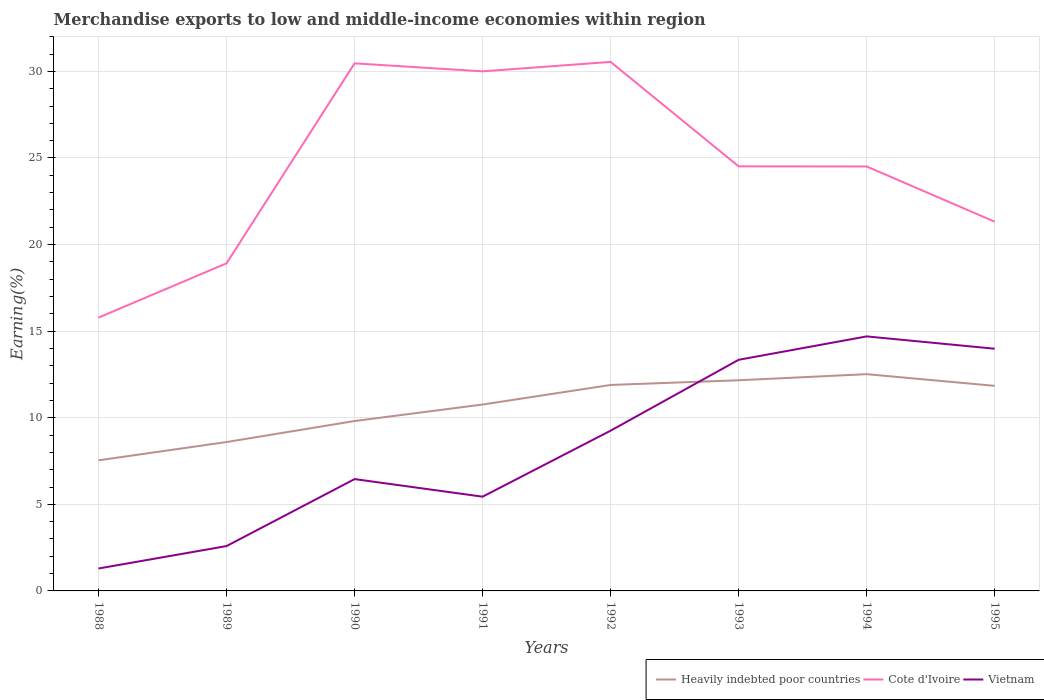How many different coloured lines are there?
Keep it short and to the point. 3. Across all years, what is the maximum percentage of amount earned from merchandise exports in Cote d'Ivoire?
Provide a short and direct response. 15.78. What is the total percentage of amount earned from merchandise exports in Vietnam in the graph?
Keep it short and to the point. -7.9. What is the difference between the highest and the second highest percentage of amount earned from merchandise exports in Heavily indebted poor countries?
Provide a succinct answer. 4.97. What is the difference between the highest and the lowest percentage of amount earned from merchandise exports in Vietnam?
Your response must be concise. 4. Is the percentage of amount earned from merchandise exports in Cote d'Ivoire strictly greater than the percentage of amount earned from merchandise exports in Heavily indebted poor countries over the years?
Your answer should be compact. No. What is the difference between two consecutive major ticks on the Y-axis?
Give a very brief answer. 5. Are the values on the major ticks of Y-axis written in scientific E-notation?
Offer a terse response. No. How are the legend labels stacked?
Give a very brief answer. Horizontal. What is the title of the graph?
Your answer should be compact. Merchandise exports to low and middle-income economies within region. Does "Lesotho" appear as one of the legend labels in the graph?
Make the answer very short. No. What is the label or title of the X-axis?
Ensure brevity in your answer.  Years. What is the label or title of the Y-axis?
Your response must be concise. Earning(%). What is the Earning(%) in Heavily indebted poor countries in 1988?
Keep it short and to the point. 7.54. What is the Earning(%) in Cote d'Ivoire in 1988?
Ensure brevity in your answer.  15.78. What is the Earning(%) in Vietnam in 1988?
Keep it short and to the point. 1.29. What is the Earning(%) of Heavily indebted poor countries in 1989?
Your answer should be very brief. 8.6. What is the Earning(%) in Cote d'Ivoire in 1989?
Offer a very short reply. 18.92. What is the Earning(%) in Vietnam in 1989?
Your answer should be compact. 2.59. What is the Earning(%) of Heavily indebted poor countries in 1990?
Offer a very short reply. 9.81. What is the Earning(%) in Cote d'Ivoire in 1990?
Offer a terse response. 30.46. What is the Earning(%) of Vietnam in 1990?
Your response must be concise. 6.46. What is the Earning(%) in Heavily indebted poor countries in 1991?
Offer a terse response. 10.76. What is the Earning(%) in Cote d'Ivoire in 1991?
Your answer should be very brief. 30. What is the Earning(%) of Vietnam in 1991?
Give a very brief answer. 5.44. What is the Earning(%) of Heavily indebted poor countries in 1992?
Your response must be concise. 11.89. What is the Earning(%) of Cote d'Ivoire in 1992?
Your response must be concise. 30.55. What is the Earning(%) of Vietnam in 1992?
Your response must be concise. 9.25. What is the Earning(%) of Heavily indebted poor countries in 1993?
Make the answer very short. 12.16. What is the Earning(%) in Cote d'Ivoire in 1993?
Ensure brevity in your answer.  24.51. What is the Earning(%) in Vietnam in 1993?
Keep it short and to the point. 13.35. What is the Earning(%) of Heavily indebted poor countries in 1994?
Ensure brevity in your answer.  12.52. What is the Earning(%) in Cote d'Ivoire in 1994?
Give a very brief answer. 24.51. What is the Earning(%) in Vietnam in 1994?
Provide a succinct answer. 14.7. What is the Earning(%) of Heavily indebted poor countries in 1995?
Offer a terse response. 11.84. What is the Earning(%) of Cote d'Ivoire in 1995?
Your response must be concise. 21.32. What is the Earning(%) of Vietnam in 1995?
Ensure brevity in your answer.  13.98. Across all years, what is the maximum Earning(%) in Heavily indebted poor countries?
Give a very brief answer. 12.52. Across all years, what is the maximum Earning(%) of Cote d'Ivoire?
Make the answer very short. 30.55. Across all years, what is the maximum Earning(%) of Vietnam?
Your answer should be very brief. 14.7. Across all years, what is the minimum Earning(%) of Heavily indebted poor countries?
Your answer should be compact. 7.54. Across all years, what is the minimum Earning(%) in Cote d'Ivoire?
Your answer should be very brief. 15.78. Across all years, what is the minimum Earning(%) in Vietnam?
Your answer should be very brief. 1.29. What is the total Earning(%) in Heavily indebted poor countries in the graph?
Ensure brevity in your answer.  85.12. What is the total Earning(%) in Cote d'Ivoire in the graph?
Ensure brevity in your answer.  196.05. What is the total Earning(%) in Vietnam in the graph?
Your answer should be very brief. 67.06. What is the difference between the Earning(%) in Heavily indebted poor countries in 1988 and that in 1989?
Offer a very short reply. -1.06. What is the difference between the Earning(%) of Cote d'Ivoire in 1988 and that in 1989?
Provide a short and direct response. -3.14. What is the difference between the Earning(%) of Vietnam in 1988 and that in 1989?
Ensure brevity in your answer.  -1.3. What is the difference between the Earning(%) of Heavily indebted poor countries in 1988 and that in 1990?
Keep it short and to the point. -2.27. What is the difference between the Earning(%) of Cote d'Ivoire in 1988 and that in 1990?
Keep it short and to the point. -14.68. What is the difference between the Earning(%) in Vietnam in 1988 and that in 1990?
Offer a terse response. -5.16. What is the difference between the Earning(%) of Heavily indebted poor countries in 1988 and that in 1991?
Give a very brief answer. -3.22. What is the difference between the Earning(%) in Cote d'Ivoire in 1988 and that in 1991?
Offer a very short reply. -14.22. What is the difference between the Earning(%) of Vietnam in 1988 and that in 1991?
Offer a terse response. -4.15. What is the difference between the Earning(%) in Heavily indebted poor countries in 1988 and that in 1992?
Offer a terse response. -4.35. What is the difference between the Earning(%) in Cote d'Ivoire in 1988 and that in 1992?
Provide a short and direct response. -14.76. What is the difference between the Earning(%) in Vietnam in 1988 and that in 1992?
Your response must be concise. -7.96. What is the difference between the Earning(%) of Heavily indebted poor countries in 1988 and that in 1993?
Make the answer very short. -4.62. What is the difference between the Earning(%) of Cote d'Ivoire in 1988 and that in 1993?
Make the answer very short. -8.73. What is the difference between the Earning(%) of Vietnam in 1988 and that in 1993?
Give a very brief answer. -12.05. What is the difference between the Earning(%) in Heavily indebted poor countries in 1988 and that in 1994?
Offer a terse response. -4.97. What is the difference between the Earning(%) in Cote d'Ivoire in 1988 and that in 1994?
Provide a succinct answer. -8.73. What is the difference between the Earning(%) of Vietnam in 1988 and that in 1994?
Your answer should be very brief. -13.4. What is the difference between the Earning(%) in Heavily indebted poor countries in 1988 and that in 1995?
Give a very brief answer. -4.3. What is the difference between the Earning(%) in Cote d'Ivoire in 1988 and that in 1995?
Offer a very short reply. -5.54. What is the difference between the Earning(%) in Vietnam in 1988 and that in 1995?
Make the answer very short. -12.69. What is the difference between the Earning(%) in Heavily indebted poor countries in 1989 and that in 1990?
Offer a terse response. -1.21. What is the difference between the Earning(%) of Cote d'Ivoire in 1989 and that in 1990?
Provide a short and direct response. -11.55. What is the difference between the Earning(%) of Vietnam in 1989 and that in 1990?
Provide a short and direct response. -3.87. What is the difference between the Earning(%) of Heavily indebted poor countries in 1989 and that in 1991?
Make the answer very short. -2.17. What is the difference between the Earning(%) of Cote d'Ivoire in 1989 and that in 1991?
Make the answer very short. -11.08. What is the difference between the Earning(%) of Vietnam in 1989 and that in 1991?
Offer a terse response. -2.85. What is the difference between the Earning(%) in Heavily indebted poor countries in 1989 and that in 1992?
Ensure brevity in your answer.  -3.3. What is the difference between the Earning(%) in Cote d'Ivoire in 1989 and that in 1992?
Keep it short and to the point. -11.63. What is the difference between the Earning(%) in Vietnam in 1989 and that in 1992?
Provide a succinct answer. -6.66. What is the difference between the Earning(%) in Heavily indebted poor countries in 1989 and that in 1993?
Provide a short and direct response. -3.57. What is the difference between the Earning(%) of Cote d'Ivoire in 1989 and that in 1993?
Offer a terse response. -5.6. What is the difference between the Earning(%) in Vietnam in 1989 and that in 1993?
Your answer should be compact. -10.76. What is the difference between the Earning(%) of Heavily indebted poor countries in 1989 and that in 1994?
Your answer should be very brief. -3.92. What is the difference between the Earning(%) of Cote d'Ivoire in 1989 and that in 1994?
Ensure brevity in your answer.  -5.59. What is the difference between the Earning(%) of Vietnam in 1989 and that in 1994?
Your response must be concise. -12.11. What is the difference between the Earning(%) in Heavily indebted poor countries in 1989 and that in 1995?
Offer a terse response. -3.24. What is the difference between the Earning(%) of Cote d'Ivoire in 1989 and that in 1995?
Give a very brief answer. -2.4. What is the difference between the Earning(%) of Vietnam in 1989 and that in 1995?
Offer a very short reply. -11.4. What is the difference between the Earning(%) in Heavily indebted poor countries in 1990 and that in 1991?
Your response must be concise. -0.95. What is the difference between the Earning(%) in Cote d'Ivoire in 1990 and that in 1991?
Provide a succinct answer. 0.46. What is the difference between the Earning(%) of Vietnam in 1990 and that in 1991?
Your response must be concise. 1.02. What is the difference between the Earning(%) of Heavily indebted poor countries in 1990 and that in 1992?
Offer a terse response. -2.08. What is the difference between the Earning(%) in Cote d'Ivoire in 1990 and that in 1992?
Keep it short and to the point. -0.08. What is the difference between the Earning(%) in Vietnam in 1990 and that in 1992?
Keep it short and to the point. -2.8. What is the difference between the Earning(%) in Heavily indebted poor countries in 1990 and that in 1993?
Make the answer very short. -2.35. What is the difference between the Earning(%) of Cote d'Ivoire in 1990 and that in 1993?
Make the answer very short. 5.95. What is the difference between the Earning(%) in Vietnam in 1990 and that in 1993?
Provide a short and direct response. -6.89. What is the difference between the Earning(%) of Heavily indebted poor countries in 1990 and that in 1994?
Give a very brief answer. -2.71. What is the difference between the Earning(%) in Cote d'Ivoire in 1990 and that in 1994?
Offer a very short reply. 5.95. What is the difference between the Earning(%) of Vietnam in 1990 and that in 1994?
Offer a very short reply. -8.24. What is the difference between the Earning(%) of Heavily indebted poor countries in 1990 and that in 1995?
Your answer should be very brief. -2.03. What is the difference between the Earning(%) in Cote d'Ivoire in 1990 and that in 1995?
Give a very brief answer. 9.14. What is the difference between the Earning(%) in Vietnam in 1990 and that in 1995?
Your answer should be very brief. -7.53. What is the difference between the Earning(%) in Heavily indebted poor countries in 1991 and that in 1992?
Keep it short and to the point. -1.13. What is the difference between the Earning(%) in Cote d'Ivoire in 1991 and that in 1992?
Provide a succinct answer. -0.55. What is the difference between the Earning(%) in Vietnam in 1991 and that in 1992?
Offer a terse response. -3.81. What is the difference between the Earning(%) of Heavily indebted poor countries in 1991 and that in 1993?
Your response must be concise. -1.4. What is the difference between the Earning(%) of Cote d'Ivoire in 1991 and that in 1993?
Ensure brevity in your answer.  5.49. What is the difference between the Earning(%) in Vietnam in 1991 and that in 1993?
Your answer should be very brief. -7.9. What is the difference between the Earning(%) of Heavily indebted poor countries in 1991 and that in 1994?
Make the answer very short. -1.75. What is the difference between the Earning(%) in Cote d'Ivoire in 1991 and that in 1994?
Provide a succinct answer. 5.49. What is the difference between the Earning(%) in Vietnam in 1991 and that in 1994?
Your response must be concise. -9.25. What is the difference between the Earning(%) in Heavily indebted poor countries in 1991 and that in 1995?
Offer a terse response. -1.08. What is the difference between the Earning(%) in Cote d'Ivoire in 1991 and that in 1995?
Give a very brief answer. 8.68. What is the difference between the Earning(%) of Vietnam in 1991 and that in 1995?
Offer a very short reply. -8.54. What is the difference between the Earning(%) in Heavily indebted poor countries in 1992 and that in 1993?
Provide a short and direct response. -0.27. What is the difference between the Earning(%) of Cote d'Ivoire in 1992 and that in 1993?
Make the answer very short. 6.03. What is the difference between the Earning(%) of Vietnam in 1992 and that in 1993?
Offer a terse response. -4.09. What is the difference between the Earning(%) of Heavily indebted poor countries in 1992 and that in 1994?
Your response must be concise. -0.62. What is the difference between the Earning(%) of Cote d'Ivoire in 1992 and that in 1994?
Your answer should be very brief. 6.04. What is the difference between the Earning(%) in Vietnam in 1992 and that in 1994?
Give a very brief answer. -5.44. What is the difference between the Earning(%) of Heavily indebted poor countries in 1992 and that in 1995?
Offer a very short reply. 0.05. What is the difference between the Earning(%) of Cote d'Ivoire in 1992 and that in 1995?
Your answer should be compact. 9.23. What is the difference between the Earning(%) in Vietnam in 1992 and that in 1995?
Ensure brevity in your answer.  -4.73. What is the difference between the Earning(%) in Heavily indebted poor countries in 1993 and that in 1994?
Give a very brief answer. -0.35. What is the difference between the Earning(%) of Cote d'Ivoire in 1993 and that in 1994?
Ensure brevity in your answer.  0.01. What is the difference between the Earning(%) of Vietnam in 1993 and that in 1994?
Your answer should be compact. -1.35. What is the difference between the Earning(%) in Heavily indebted poor countries in 1993 and that in 1995?
Offer a very short reply. 0.32. What is the difference between the Earning(%) of Cote d'Ivoire in 1993 and that in 1995?
Provide a succinct answer. 3.19. What is the difference between the Earning(%) in Vietnam in 1993 and that in 1995?
Ensure brevity in your answer.  -0.64. What is the difference between the Earning(%) in Heavily indebted poor countries in 1994 and that in 1995?
Ensure brevity in your answer.  0.67. What is the difference between the Earning(%) of Cote d'Ivoire in 1994 and that in 1995?
Ensure brevity in your answer.  3.19. What is the difference between the Earning(%) in Vietnam in 1994 and that in 1995?
Your answer should be very brief. 0.71. What is the difference between the Earning(%) of Heavily indebted poor countries in 1988 and the Earning(%) of Cote d'Ivoire in 1989?
Ensure brevity in your answer.  -11.38. What is the difference between the Earning(%) in Heavily indebted poor countries in 1988 and the Earning(%) in Vietnam in 1989?
Offer a very short reply. 4.95. What is the difference between the Earning(%) of Cote d'Ivoire in 1988 and the Earning(%) of Vietnam in 1989?
Offer a terse response. 13.19. What is the difference between the Earning(%) in Heavily indebted poor countries in 1988 and the Earning(%) in Cote d'Ivoire in 1990?
Provide a short and direct response. -22.92. What is the difference between the Earning(%) in Heavily indebted poor countries in 1988 and the Earning(%) in Vietnam in 1990?
Ensure brevity in your answer.  1.08. What is the difference between the Earning(%) of Cote d'Ivoire in 1988 and the Earning(%) of Vietnam in 1990?
Your answer should be compact. 9.32. What is the difference between the Earning(%) in Heavily indebted poor countries in 1988 and the Earning(%) in Cote d'Ivoire in 1991?
Offer a terse response. -22.46. What is the difference between the Earning(%) in Heavily indebted poor countries in 1988 and the Earning(%) in Vietnam in 1991?
Make the answer very short. 2.1. What is the difference between the Earning(%) of Cote d'Ivoire in 1988 and the Earning(%) of Vietnam in 1991?
Provide a short and direct response. 10.34. What is the difference between the Earning(%) of Heavily indebted poor countries in 1988 and the Earning(%) of Cote d'Ivoire in 1992?
Provide a succinct answer. -23.01. What is the difference between the Earning(%) of Heavily indebted poor countries in 1988 and the Earning(%) of Vietnam in 1992?
Your response must be concise. -1.71. What is the difference between the Earning(%) of Cote d'Ivoire in 1988 and the Earning(%) of Vietnam in 1992?
Ensure brevity in your answer.  6.53. What is the difference between the Earning(%) of Heavily indebted poor countries in 1988 and the Earning(%) of Cote d'Ivoire in 1993?
Your answer should be compact. -16.97. What is the difference between the Earning(%) in Heavily indebted poor countries in 1988 and the Earning(%) in Vietnam in 1993?
Your answer should be very brief. -5.8. What is the difference between the Earning(%) in Cote d'Ivoire in 1988 and the Earning(%) in Vietnam in 1993?
Provide a succinct answer. 2.44. What is the difference between the Earning(%) in Heavily indebted poor countries in 1988 and the Earning(%) in Cote d'Ivoire in 1994?
Provide a succinct answer. -16.97. What is the difference between the Earning(%) of Heavily indebted poor countries in 1988 and the Earning(%) of Vietnam in 1994?
Offer a very short reply. -7.16. What is the difference between the Earning(%) in Cote d'Ivoire in 1988 and the Earning(%) in Vietnam in 1994?
Provide a succinct answer. 1.09. What is the difference between the Earning(%) in Heavily indebted poor countries in 1988 and the Earning(%) in Cote d'Ivoire in 1995?
Keep it short and to the point. -13.78. What is the difference between the Earning(%) of Heavily indebted poor countries in 1988 and the Earning(%) of Vietnam in 1995?
Provide a succinct answer. -6.44. What is the difference between the Earning(%) in Cote d'Ivoire in 1988 and the Earning(%) in Vietnam in 1995?
Keep it short and to the point. 1.8. What is the difference between the Earning(%) in Heavily indebted poor countries in 1989 and the Earning(%) in Cote d'Ivoire in 1990?
Give a very brief answer. -21.87. What is the difference between the Earning(%) of Heavily indebted poor countries in 1989 and the Earning(%) of Vietnam in 1990?
Keep it short and to the point. 2.14. What is the difference between the Earning(%) in Cote d'Ivoire in 1989 and the Earning(%) in Vietnam in 1990?
Offer a terse response. 12.46. What is the difference between the Earning(%) of Heavily indebted poor countries in 1989 and the Earning(%) of Cote d'Ivoire in 1991?
Provide a short and direct response. -21.4. What is the difference between the Earning(%) in Heavily indebted poor countries in 1989 and the Earning(%) in Vietnam in 1991?
Keep it short and to the point. 3.15. What is the difference between the Earning(%) in Cote d'Ivoire in 1989 and the Earning(%) in Vietnam in 1991?
Offer a very short reply. 13.48. What is the difference between the Earning(%) in Heavily indebted poor countries in 1989 and the Earning(%) in Cote d'Ivoire in 1992?
Ensure brevity in your answer.  -21.95. What is the difference between the Earning(%) of Heavily indebted poor countries in 1989 and the Earning(%) of Vietnam in 1992?
Offer a very short reply. -0.66. What is the difference between the Earning(%) of Cote d'Ivoire in 1989 and the Earning(%) of Vietnam in 1992?
Offer a very short reply. 9.66. What is the difference between the Earning(%) of Heavily indebted poor countries in 1989 and the Earning(%) of Cote d'Ivoire in 1993?
Provide a short and direct response. -15.92. What is the difference between the Earning(%) of Heavily indebted poor countries in 1989 and the Earning(%) of Vietnam in 1993?
Ensure brevity in your answer.  -4.75. What is the difference between the Earning(%) in Cote d'Ivoire in 1989 and the Earning(%) in Vietnam in 1993?
Keep it short and to the point. 5.57. What is the difference between the Earning(%) of Heavily indebted poor countries in 1989 and the Earning(%) of Cote d'Ivoire in 1994?
Provide a succinct answer. -15.91. What is the difference between the Earning(%) in Heavily indebted poor countries in 1989 and the Earning(%) in Vietnam in 1994?
Your response must be concise. -6.1. What is the difference between the Earning(%) of Cote d'Ivoire in 1989 and the Earning(%) of Vietnam in 1994?
Your response must be concise. 4.22. What is the difference between the Earning(%) in Heavily indebted poor countries in 1989 and the Earning(%) in Cote d'Ivoire in 1995?
Your answer should be very brief. -12.72. What is the difference between the Earning(%) in Heavily indebted poor countries in 1989 and the Earning(%) in Vietnam in 1995?
Ensure brevity in your answer.  -5.39. What is the difference between the Earning(%) of Cote d'Ivoire in 1989 and the Earning(%) of Vietnam in 1995?
Keep it short and to the point. 4.93. What is the difference between the Earning(%) in Heavily indebted poor countries in 1990 and the Earning(%) in Cote d'Ivoire in 1991?
Make the answer very short. -20.19. What is the difference between the Earning(%) of Heavily indebted poor countries in 1990 and the Earning(%) of Vietnam in 1991?
Your response must be concise. 4.37. What is the difference between the Earning(%) of Cote d'Ivoire in 1990 and the Earning(%) of Vietnam in 1991?
Your answer should be compact. 25.02. What is the difference between the Earning(%) of Heavily indebted poor countries in 1990 and the Earning(%) of Cote d'Ivoire in 1992?
Offer a terse response. -20.74. What is the difference between the Earning(%) of Heavily indebted poor countries in 1990 and the Earning(%) of Vietnam in 1992?
Keep it short and to the point. 0.56. What is the difference between the Earning(%) of Cote d'Ivoire in 1990 and the Earning(%) of Vietnam in 1992?
Ensure brevity in your answer.  21.21. What is the difference between the Earning(%) in Heavily indebted poor countries in 1990 and the Earning(%) in Cote d'Ivoire in 1993?
Ensure brevity in your answer.  -14.7. What is the difference between the Earning(%) of Heavily indebted poor countries in 1990 and the Earning(%) of Vietnam in 1993?
Your answer should be very brief. -3.53. What is the difference between the Earning(%) in Cote d'Ivoire in 1990 and the Earning(%) in Vietnam in 1993?
Your response must be concise. 17.12. What is the difference between the Earning(%) of Heavily indebted poor countries in 1990 and the Earning(%) of Cote d'Ivoire in 1994?
Ensure brevity in your answer.  -14.7. What is the difference between the Earning(%) in Heavily indebted poor countries in 1990 and the Earning(%) in Vietnam in 1994?
Make the answer very short. -4.89. What is the difference between the Earning(%) in Cote d'Ivoire in 1990 and the Earning(%) in Vietnam in 1994?
Provide a short and direct response. 15.77. What is the difference between the Earning(%) in Heavily indebted poor countries in 1990 and the Earning(%) in Cote d'Ivoire in 1995?
Provide a short and direct response. -11.51. What is the difference between the Earning(%) in Heavily indebted poor countries in 1990 and the Earning(%) in Vietnam in 1995?
Your answer should be very brief. -4.17. What is the difference between the Earning(%) of Cote d'Ivoire in 1990 and the Earning(%) of Vietnam in 1995?
Ensure brevity in your answer.  16.48. What is the difference between the Earning(%) in Heavily indebted poor countries in 1991 and the Earning(%) in Cote d'Ivoire in 1992?
Your response must be concise. -19.78. What is the difference between the Earning(%) of Heavily indebted poor countries in 1991 and the Earning(%) of Vietnam in 1992?
Make the answer very short. 1.51. What is the difference between the Earning(%) in Cote d'Ivoire in 1991 and the Earning(%) in Vietnam in 1992?
Give a very brief answer. 20.75. What is the difference between the Earning(%) in Heavily indebted poor countries in 1991 and the Earning(%) in Cote d'Ivoire in 1993?
Your response must be concise. -13.75. What is the difference between the Earning(%) of Heavily indebted poor countries in 1991 and the Earning(%) of Vietnam in 1993?
Make the answer very short. -2.58. What is the difference between the Earning(%) in Cote d'Ivoire in 1991 and the Earning(%) in Vietnam in 1993?
Give a very brief answer. 16.66. What is the difference between the Earning(%) in Heavily indebted poor countries in 1991 and the Earning(%) in Cote d'Ivoire in 1994?
Provide a short and direct response. -13.75. What is the difference between the Earning(%) of Heavily indebted poor countries in 1991 and the Earning(%) of Vietnam in 1994?
Ensure brevity in your answer.  -3.93. What is the difference between the Earning(%) in Cote d'Ivoire in 1991 and the Earning(%) in Vietnam in 1994?
Provide a succinct answer. 15.31. What is the difference between the Earning(%) in Heavily indebted poor countries in 1991 and the Earning(%) in Cote d'Ivoire in 1995?
Your answer should be very brief. -10.56. What is the difference between the Earning(%) of Heavily indebted poor countries in 1991 and the Earning(%) of Vietnam in 1995?
Provide a short and direct response. -3.22. What is the difference between the Earning(%) of Cote d'Ivoire in 1991 and the Earning(%) of Vietnam in 1995?
Your response must be concise. 16.02. What is the difference between the Earning(%) of Heavily indebted poor countries in 1992 and the Earning(%) of Cote d'Ivoire in 1993?
Provide a succinct answer. -12.62. What is the difference between the Earning(%) of Heavily indebted poor countries in 1992 and the Earning(%) of Vietnam in 1993?
Give a very brief answer. -1.45. What is the difference between the Earning(%) in Cote d'Ivoire in 1992 and the Earning(%) in Vietnam in 1993?
Make the answer very short. 17.2. What is the difference between the Earning(%) in Heavily indebted poor countries in 1992 and the Earning(%) in Cote d'Ivoire in 1994?
Your answer should be very brief. -12.62. What is the difference between the Earning(%) of Heavily indebted poor countries in 1992 and the Earning(%) of Vietnam in 1994?
Your answer should be compact. -2.8. What is the difference between the Earning(%) in Cote d'Ivoire in 1992 and the Earning(%) in Vietnam in 1994?
Give a very brief answer. 15.85. What is the difference between the Earning(%) in Heavily indebted poor countries in 1992 and the Earning(%) in Cote d'Ivoire in 1995?
Keep it short and to the point. -9.43. What is the difference between the Earning(%) in Heavily indebted poor countries in 1992 and the Earning(%) in Vietnam in 1995?
Your response must be concise. -2.09. What is the difference between the Earning(%) in Cote d'Ivoire in 1992 and the Earning(%) in Vietnam in 1995?
Make the answer very short. 16.56. What is the difference between the Earning(%) of Heavily indebted poor countries in 1993 and the Earning(%) of Cote d'Ivoire in 1994?
Your answer should be very brief. -12.34. What is the difference between the Earning(%) of Heavily indebted poor countries in 1993 and the Earning(%) of Vietnam in 1994?
Provide a succinct answer. -2.53. What is the difference between the Earning(%) in Cote d'Ivoire in 1993 and the Earning(%) in Vietnam in 1994?
Your answer should be compact. 9.82. What is the difference between the Earning(%) of Heavily indebted poor countries in 1993 and the Earning(%) of Cote d'Ivoire in 1995?
Provide a succinct answer. -9.16. What is the difference between the Earning(%) in Heavily indebted poor countries in 1993 and the Earning(%) in Vietnam in 1995?
Make the answer very short. -1.82. What is the difference between the Earning(%) in Cote d'Ivoire in 1993 and the Earning(%) in Vietnam in 1995?
Give a very brief answer. 10.53. What is the difference between the Earning(%) of Heavily indebted poor countries in 1994 and the Earning(%) of Cote d'Ivoire in 1995?
Your answer should be very brief. -8.8. What is the difference between the Earning(%) of Heavily indebted poor countries in 1994 and the Earning(%) of Vietnam in 1995?
Your answer should be compact. -1.47. What is the difference between the Earning(%) of Cote d'Ivoire in 1994 and the Earning(%) of Vietnam in 1995?
Provide a short and direct response. 10.52. What is the average Earning(%) of Heavily indebted poor countries per year?
Provide a succinct answer. 10.64. What is the average Earning(%) of Cote d'Ivoire per year?
Your answer should be compact. 24.51. What is the average Earning(%) in Vietnam per year?
Offer a very short reply. 8.38. In the year 1988, what is the difference between the Earning(%) of Heavily indebted poor countries and Earning(%) of Cote d'Ivoire?
Your answer should be very brief. -8.24. In the year 1988, what is the difference between the Earning(%) of Heavily indebted poor countries and Earning(%) of Vietnam?
Ensure brevity in your answer.  6.25. In the year 1988, what is the difference between the Earning(%) in Cote d'Ivoire and Earning(%) in Vietnam?
Give a very brief answer. 14.49. In the year 1989, what is the difference between the Earning(%) in Heavily indebted poor countries and Earning(%) in Cote d'Ivoire?
Make the answer very short. -10.32. In the year 1989, what is the difference between the Earning(%) in Heavily indebted poor countries and Earning(%) in Vietnam?
Offer a very short reply. 6.01. In the year 1989, what is the difference between the Earning(%) of Cote d'Ivoire and Earning(%) of Vietnam?
Give a very brief answer. 16.33. In the year 1990, what is the difference between the Earning(%) of Heavily indebted poor countries and Earning(%) of Cote d'Ivoire?
Ensure brevity in your answer.  -20.65. In the year 1990, what is the difference between the Earning(%) of Heavily indebted poor countries and Earning(%) of Vietnam?
Your response must be concise. 3.35. In the year 1990, what is the difference between the Earning(%) in Cote d'Ivoire and Earning(%) in Vietnam?
Give a very brief answer. 24.01. In the year 1991, what is the difference between the Earning(%) of Heavily indebted poor countries and Earning(%) of Cote d'Ivoire?
Provide a short and direct response. -19.24. In the year 1991, what is the difference between the Earning(%) of Heavily indebted poor countries and Earning(%) of Vietnam?
Offer a very short reply. 5.32. In the year 1991, what is the difference between the Earning(%) of Cote d'Ivoire and Earning(%) of Vietnam?
Provide a short and direct response. 24.56. In the year 1992, what is the difference between the Earning(%) of Heavily indebted poor countries and Earning(%) of Cote d'Ivoire?
Keep it short and to the point. -18.65. In the year 1992, what is the difference between the Earning(%) of Heavily indebted poor countries and Earning(%) of Vietnam?
Offer a terse response. 2.64. In the year 1992, what is the difference between the Earning(%) of Cote d'Ivoire and Earning(%) of Vietnam?
Your answer should be very brief. 21.29. In the year 1993, what is the difference between the Earning(%) in Heavily indebted poor countries and Earning(%) in Cote d'Ivoire?
Make the answer very short. -12.35. In the year 1993, what is the difference between the Earning(%) of Heavily indebted poor countries and Earning(%) of Vietnam?
Ensure brevity in your answer.  -1.18. In the year 1993, what is the difference between the Earning(%) in Cote d'Ivoire and Earning(%) in Vietnam?
Provide a succinct answer. 11.17. In the year 1994, what is the difference between the Earning(%) in Heavily indebted poor countries and Earning(%) in Cote d'Ivoire?
Provide a short and direct response. -11.99. In the year 1994, what is the difference between the Earning(%) of Heavily indebted poor countries and Earning(%) of Vietnam?
Your answer should be very brief. -2.18. In the year 1994, what is the difference between the Earning(%) in Cote d'Ivoire and Earning(%) in Vietnam?
Provide a succinct answer. 9.81. In the year 1995, what is the difference between the Earning(%) in Heavily indebted poor countries and Earning(%) in Cote d'Ivoire?
Keep it short and to the point. -9.48. In the year 1995, what is the difference between the Earning(%) in Heavily indebted poor countries and Earning(%) in Vietnam?
Your answer should be compact. -2.14. In the year 1995, what is the difference between the Earning(%) of Cote d'Ivoire and Earning(%) of Vietnam?
Give a very brief answer. 7.34. What is the ratio of the Earning(%) of Heavily indebted poor countries in 1988 to that in 1989?
Your response must be concise. 0.88. What is the ratio of the Earning(%) of Cote d'Ivoire in 1988 to that in 1989?
Offer a very short reply. 0.83. What is the ratio of the Earning(%) in Vietnam in 1988 to that in 1989?
Give a very brief answer. 0.5. What is the ratio of the Earning(%) in Heavily indebted poor countries in 1988 to that in 1990?
Make the answer very short. 0.77. What is the ratio of the Earning(%) of Cote d'Ivoire in 1988 to that in 1990?
Make the answer very short. 0.52. What is the ratio of the Earning(%) in Vietnam in 1988 to that in 1990?
Keep it short and to the point. 0.2. What is the ratio of the Earning(%) in Heavily indebted poor countries in 1988 to that in 1991?
Keep it short and to the point. 0.7. What is the ratio of the Earning(%) of Cote d'Ivoire in 1988 to that in 1991?
Offer a terse response. 0.53. What is the ratio of the Earning(%) in Vietnam in 1988 to that in 1991?
Your answer should be very brief. 0.24. What is the ratio of the Earning(%) in Heavily indebted poor countries in 1988 to that in 1992?
Provide a succinct answer. 0.63. What is the ratio of the Earning(%) of Cote d'Ivoire in 1988 to that in 1992?
Keep it short and to the point. 0.52. What is the ratio of the Earning(%) of Vietnam in 1988 to that in 1992?
Ensure brevity in your answer.  0.14. What is the ratio of the Earning(%) in Heavily indebted poor countries in 1988 to that in 1993?
Offer a terse response. 0.62. What is the ratio of the Earning(%) in Cote d'Ivoire in 1988 to that in 1993?
Make the answer very short. 0.64. What is the ratio of the Earning(%) in Vietnam in 1988 to that in 1993?
Provide a short and direct response. 0.1. What is the ratio of the Earning(%) in Heavily indebted poor countries in 1988 to that in 1994?
Offer a terse response. 0.6. What is the ratio of the Earning(%) of Cote d'Ivoire in 1988 to that in 1994?
Give a very brief answer. 0.64. What is the ratio of the Earning(%) in Vietnam in 1988 to that in 1994?
Your response must be concise. 0.09. What is the ratio of the Earning(%) of Heavily indebted poor countries in 1988 to that in 1995?
Provide a short and direct response. 0.64. What is the ratio of the Earning(%) of Cote d'Ivoire in 1988 to that in 1995?
Provide a succinct answer. 0.74. What is the ratio of the Earning(%) of Vietnam in 1988 to that in 1995?
Provide a short and direct response. 0.09. What is the ratio of the Earning(%) in Heavily indebted poor countries in 1989 to that in 1990?
Offer a very short reply. 0.88. What is the ratio of the Earning(%) of Cote d'Ivoire in 1989 to that in 1990?
Ensure brevity in your answer.  0.62. What is the ratio of the Earning(%) of Vietnam in 1989 to that in 1990?
Offer a terse response. 0.4. What is the ratio of the Earning(%) in Heavily indebted poor countries in 1989 to that in 1991?
Your answer should be very brief. 0.8. What is the ratio of the Earning(%) of Cote d'Ivoire in 1989 to that in 1991?
Keep it short and to the point. 0.63. What is the ratio of the Earning(%) of Vietnam in 1989 to that in 1991?
Keep it short and to the point. 0.48. What is the ratio of the Earning(%) of Heavily indebted poor countries in 1989 to that in 1992?
Your answer should be compact. 0.72. What is the ratio of the Earning(%) of Cote d'Ivoire in 1989 to that in 1992?
Provide a succinct answer. 0.62. What is the ratio of the Earning(%) in Vietnam in 1989 to that in 1992?
Provide a succinct answer. 0.28. What is the ratio of the Earning(%) in Heavily indebted poor countries in 1989 to that in 1993?
Provide a short and direct response. 0.71. What is the ratio of the Earning(%) in Cote d'Ivoire in 1989 to that in 1993?
Offer a very short reply. 0.77. What is the ratio of the Earning(%) in Vietnam in 1989 to that in 1993?
Ensure brevity in your answer.  0.19. What is the ratio of the Earning(%) of Heavily indebted poor countries in 1989 to that in 1994?
Provide a short and direct response. 0.69. What is the ratio of the Earning(%) in Cote d'Ivoire in 1989 to that in 1994?
Offer a terse response. 0.77. What is the ratio of the Earning(%) of Vietnam in 1989 to that in 1994?
Your answer should be very brief. 0.18. What is the ratio of the Earning(%) in Heavily indebted poor countries in 1989 to that in 1995?
Keep it short and to the point. 0.73. What is the ratio of the Earning(%) in Cote d'Ivoire in 1989 to that in 1995?
Ensure brevity in your answer.  0.89. What is the ratio of the Earning(%) of Vietnam in 1989 to that in 1995?
Give a very brief answer. 0.19. What is the ratio of the Earning(%) of Heavily indebted poor countries in 1990 to that in 1991?
Your response must be concise. 0.91. What is the ratio of the Earning(%) in Cote d'Ivoire in 1990 to that in 1991?
Your response must be concise. 1.02. What is the ratio of the Earning(%) in Vietnam in 1990 to that in 1991?
Offer a very short reply. 1.19. What is the ratio of the Earning(%) of Heavily indebted poor countries in 1990 to that in 1992?
Keep it short and to the point. 0.82. What is the ratio of the Earning(%) in Vietnam in 1990 to that in 1992?
Make the answer very short. 0.7. What is the ratio of the Earning(%) of Heavily indebted poor countries in 1990 to that in 1993?
Your response must be concise. 0.81. What is the ratio of the Earning(%) in Cote d'Ivoire in 1990 to that in 1993?
Offer a terse response. 1.24. What is the ratio of the Earning(%) in Vietnam in 1990 to that in 1993?
Your response must be concise. 0.48. What is the ratio of the Earning(%) in Heavily indebted poor countries in 1990 to that in 1994?
Offer a terse response. 0.78. What is the ratio of the Earning(%) of Cote d'Ivoire in 1990 to that in 1994?
Your answer should be very brief. 1.24. What is the ratio of the Earning(%) of Vietnam in 1990 to that in 1994?
Offer a very short reply. 0.44. What is the ratio of the Earning(%) in Heavily indebted poor countries in 1990 to that in 1995?
Provide a succinct answer. 0.83. What is the ratio of the Earning(%) of Cote d'Ivoire in 1990 to that in 1995?
Keep it short and to the point. 1.43. What is the ratio of the Earning(%) of Vietnam in 1990 to that in 1995?
Give a very brief answer. 0.46. What is the ratio of the Earning(%) in Heavily indebted poor countries in 1991 to that in 1992?
Provide a short and direct response. 0.91. What is the ratio of the Earning(%) of Cote d'Ivoire in 1991 to that in 1992?
Offer a very short reply. 0.98. What is the ratio of the Earning(%) of Vietnam in 1991 to that in 1992?
Your answer should be compact. 0.59. What is the ratio of the Earning(%) in Heavily indebted poor countries in 1991 to that in 1993?
Offer a very short reply. 0.88. What is the ratio of the Earning(%) of Cote d'Ivoire in 1991 to that in 1993?
Offer a very short reply. 1.22. What is the ratio of the Earning(%) in Vietnam in 1991 to that in 1993?
Offer a very short reply. 0.41. What is the ratio of the Earning(%) in Heavily indebted poor countries in 1991 to that in 1994?
Keep it short and to the point. 0.86. What is the ratio of the Earning(%) in Cote d'Ivoire in 1991 to that in 1994?
Provide a short and direct response. 1.22. What is the ratio of the Earning(%) of Vietnam in 1991 to that in 1994?
Keep it short and to the point. 0.37. What is the ratio of the Earning(%) in Heavily indebted poor countries in 1991 to that in 1995?
Give a very brief answer. 0.91. What is the ratio of the Earning(%) of Cote d'Ivoire in 1991 to that in 1995?
Keep it short and to the point. 1.41. What is the ratio of the Earning(%) of Vietnam in 1991 to that in 1995?
Offer a very short reply. 0.39. What is the ratio of the Earning(%) in Heavily indebted poor countries in 1992 to that in 1993?
Make the answer very short. 0.98. What is the ratio of the Earning(%) of Cote d'Ivoire in 1992 to that in 1993?
Give a very brief answer. 1.25. What is the ratio of the Earning(%) of Vietnam in 1992 to that in 1993?
Your answer should be compact. 0.69. What is the ratio of the Earning(%) of Heavily indebted poor countries in 1992 to that in 1994?
Make the answer very short. 0.95. What is the ratio of the Earning(%) in Cote d'Ivoire in 1992 to that in 1994?
Provide a succinct answer. 1.25. What is the ratio of the Earning(%) of Vietnam in 1992 to that in 1994?
Make the answer very short. 0.63. What is the ratio of the Earning(%) in Heavily indebted poor countries in 1992 to that in 1995?
Make the answer very short. 1. What is the ratio of the Earning(%) in Cote d'Ivoire in 1992 to that in 1995?
Keep it short and to the point. 1.43. What is the ratio of the Earning(%) in Vietnam in 1992 to that in 1995?
Provide a short and direct response. 0.66. What is the ratio of the Earning(%) in Heavily indebted poor countries in 1993 to that in 1994?
Ensure brevity in your answer.  0.97. What is the ratio of the Earning(%) in Cote d'Ivoire in 1993 to that in 1994?
Ensure brevity in your answer.  1. What is the ratio of the Earning(%) in Vietnam in 1993 to that in 1994?
Your answer should be compact. 0.91. What is the ratio of the Earning(%) of Heavily indebted poor countries in 1993 to that in 1995?
Give a very brief answer. 1.03. What is the ratio of the Earning(%) in Cote d'Ivoire in 1993 to that in 1995?
Make the answer very short. 1.15. What is the ratio of the Earning(%) in Vietnam in 1993 to that in 1995?
Provide a succinct answer. 0.95. What is the ratio of the Earning(%) in Heavily indebted poor countries in 1994 to that in 1995?
Provide a succinct answer. 1.06. What is the ratio of the Earning(%) in Cote d'Ivoire in 1994 to that in 1995?
Keep it short and to the point. 1.15. What is the ratio of the Earning(%) in Vietnam in 1994 to that in 1995?
Make the answer very short. 1.05. What is the difference between the highest and the second highest Earning(%) in Heavily indebted poor countries?
Provide a succinct answer. 0.35. What is the difference between the highest and the second highest Earning(%) of Cote d'Ivoire?
Give a very brief answer. 0.08. What is the difference between the highest and the second highest Earning(%) in Vietnam?
Ensure brevity in your answer.  0.71. What is the difference between the highest and the lowest Earning(%) in Heavily indebted poor countries?
Offer a terse response. 4.97. What is the difference between the highest and the lowest Earning(%) in Cote d'Ivoire?
Your answer should be very brief. 14.76. What is the difference between the highest and the lowest Earning(%) in Vietnam?
Provide a short and direct response. 13.4. 